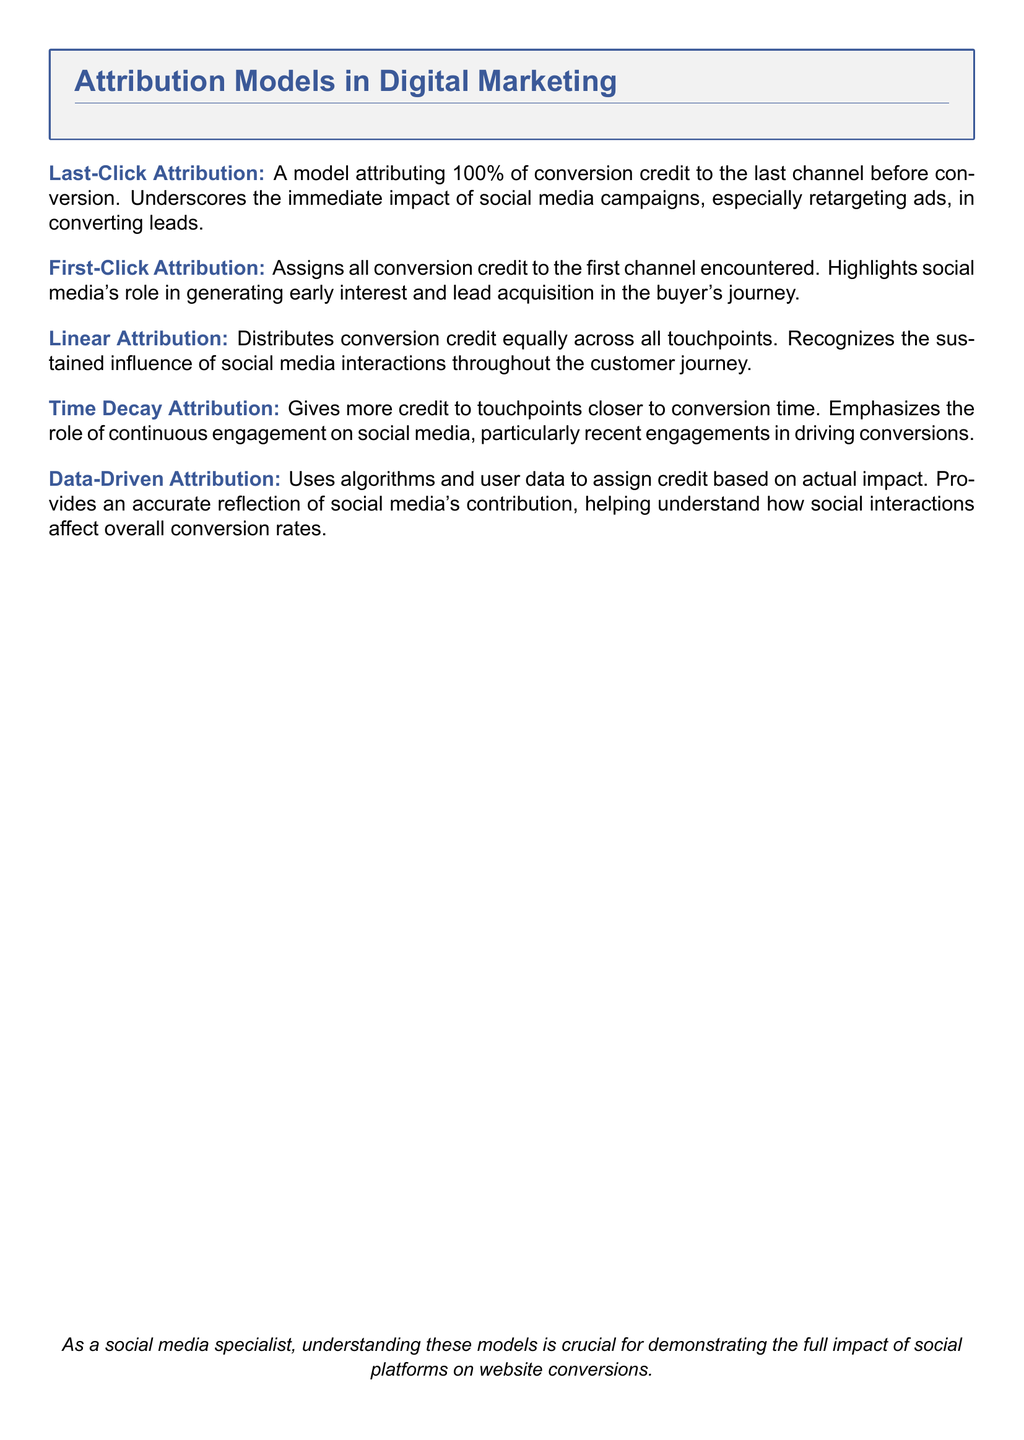What is Last-Click Attribution? Last-Click Attribution is a model attributing 100% of conversion credit to the last channel before conversion.
Answer: A model attributing 100% of conversion credit to the last channel before conversion What does First-Click Attribution emphasize? First-Click Attribution emphasizes the role of social media in generating early interest and lead acquisition in the buyer's journey.
Answer: The role of social media in generating early interest and lead acquisition How is credit distributed in Linear Attribution? In Linear Attribution, credit is distributed equally across all touchpoints.
Answer: Equally across all touchpoints What does Time Decay Attribution focus on? Time Decay Attribution focuses on giving more credit to touchpoints closer to conversion time.
Answer: More credit to touchpoints closer to conversion time What type of attribution uses algorithms and user data? Data-Driven Attribution uses algorithms and user data to assign credit based on actual impact.
Answer: Data-Driven Attribution Which attribution model underscores the impact of social media campaigns? Last-Click Attribution underscores the immediate impact of social media campaigns, especially retargeting ads.
Answer: Last-Click Attribution What is the main takeaway for social media specialists from the document? The main takeaway is understanding these models is crucial for demonstrating the full impact of social platforms on website conversions.
Answer: Understanding these models is crucial for demonstrating the full impact of social platforms on website conversions Which attribution model recognizes sustained influence throughout the journey? Linear Attribution recognizes the sustained influence of social media interactions throughout the customer journey.
Answer: Linear Attribution 